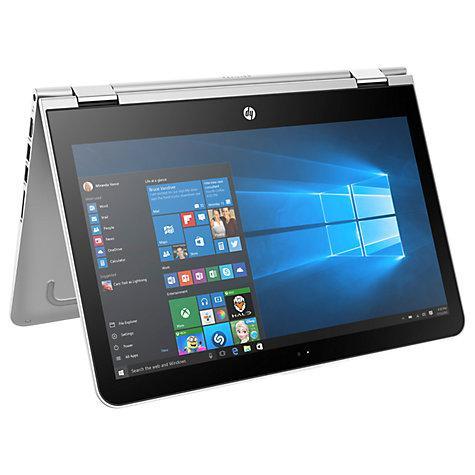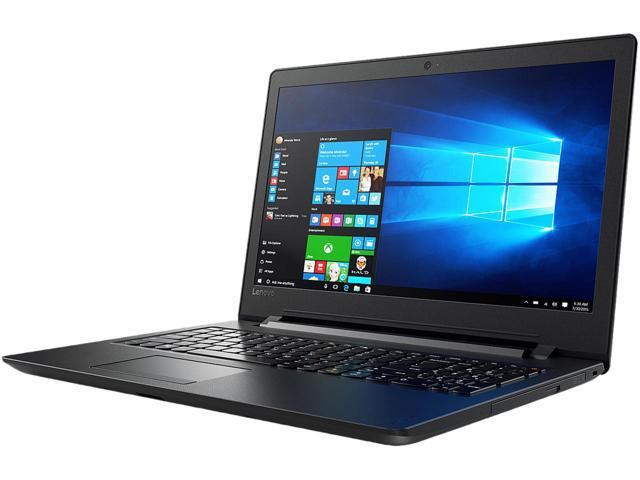The first image is the image on the left, the second image is the image on the right. Assess this claim about the two images: "An image shows at least five laptops.". Correct or not? Answer yes or no. No. The first image is the image on the left, the second image is the image on the right. For the images shown, is this caption "At least five laptop computer styles are arrayed in one image." true? Answer yes or no. No. 